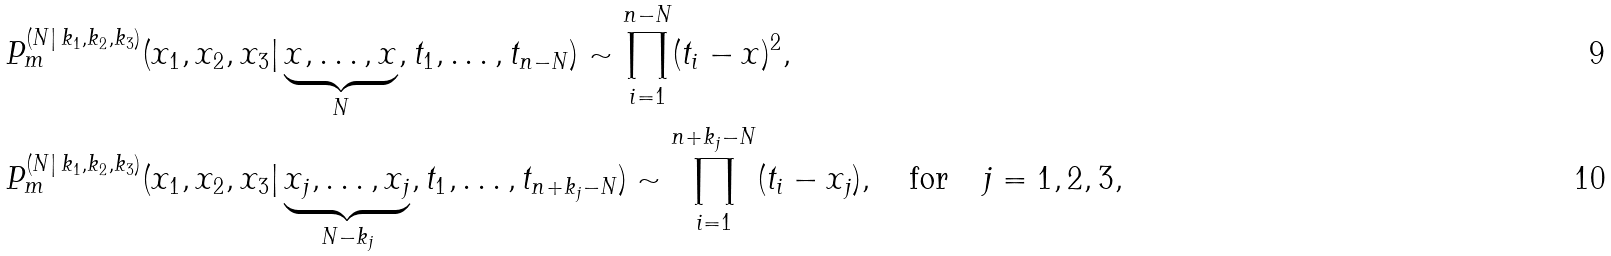<formula> <loc_0><loc_0><loc_500><loc_500>& P _ { m } ^ { ( N | \, k _ { 1 } , k _ { 2 } , k _ { 3 } ) } ( x _ { 1 } , x _ { 2 } , x _ { 3 } | \underbrace { x , \dots , x } _ { N } , t _ { 1 } , \dots , t _ { n - N } ) \sim \prod _ { i = 1 } ^ { n - N } ( t _ { i } - x ) ^ { 2 } , \\ & P _ { m } ^ { ( N | \, k _ { 1 } , k _ { 2 } , k _ { 3 } ) } ( x _ { 1 } , x _ { 2 } , x _ { 3 } | \underbrace { x _ { j } , \dots , x _ { j } } _ { N - k _ { j } } , t _ { 1 } , \dots , t _ { n + k _ { j } - N } ) \sim \prod _ { i = 1 } ^ { n + k _ { j } - N } ( t _ { i } - x _ { j } ) , \quad \text {for} \quad j = 1 , 2 , 3 ,</formula> 